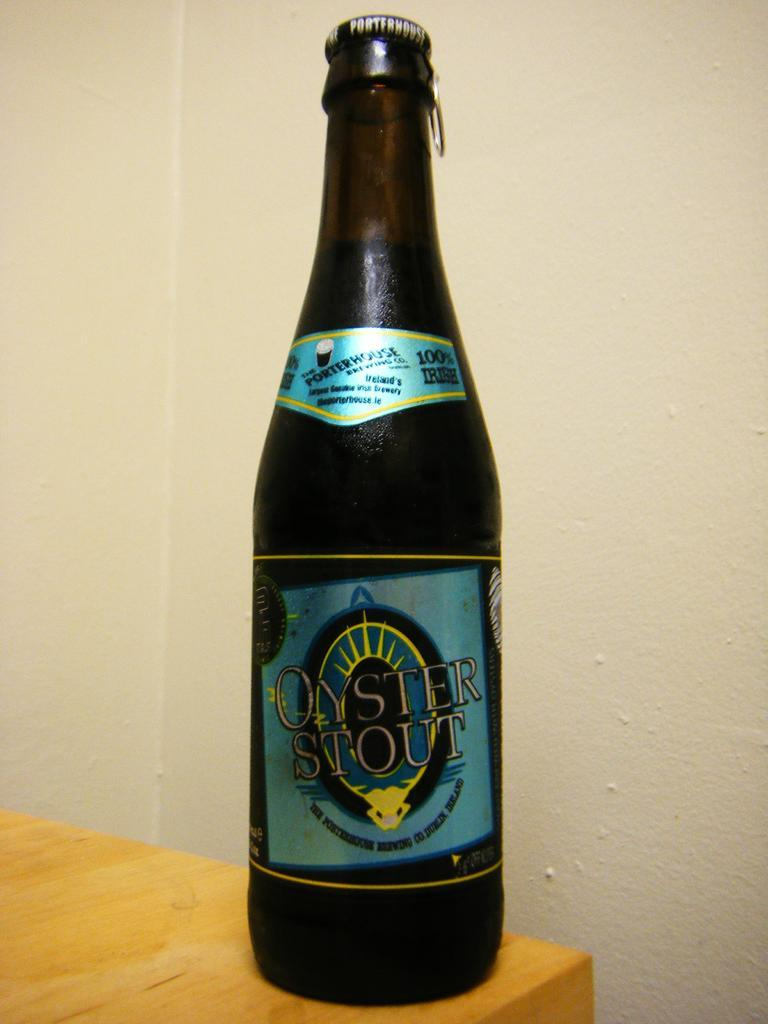<image>
Create a compact narrative representing the image presented. Brown bottle with blue and gold labels on front says Oyster Stout 